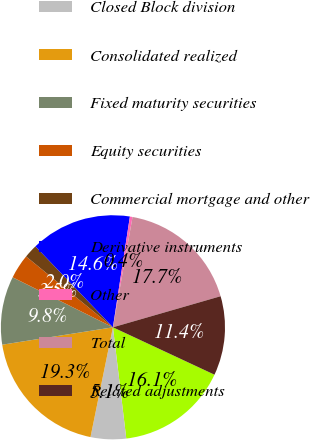Convert chart to OTSL. <chart><loc_0><loc_0><loc_500><loc_500><pie_chart><fcel>PFI excluding Closed Block<fcel>Closed Block division<fcel>Consolidated realized<fcel>Fixed maturity securities<fcel>Equity securities<fcel>Commercial mortgage and other<fcel>Derivative instruments<fcel>Other<fcel>Total<fcel>Related adjustments<nl><fcel>16.15%<fcel>5.11%<fcel>19.31%<fcel>9.84%<fcel>3.53%<fcel>1.95%<fcel>14.58%<fcel>0.38%<fcel>17.73%<fcel>11.42%<nl></chart> 